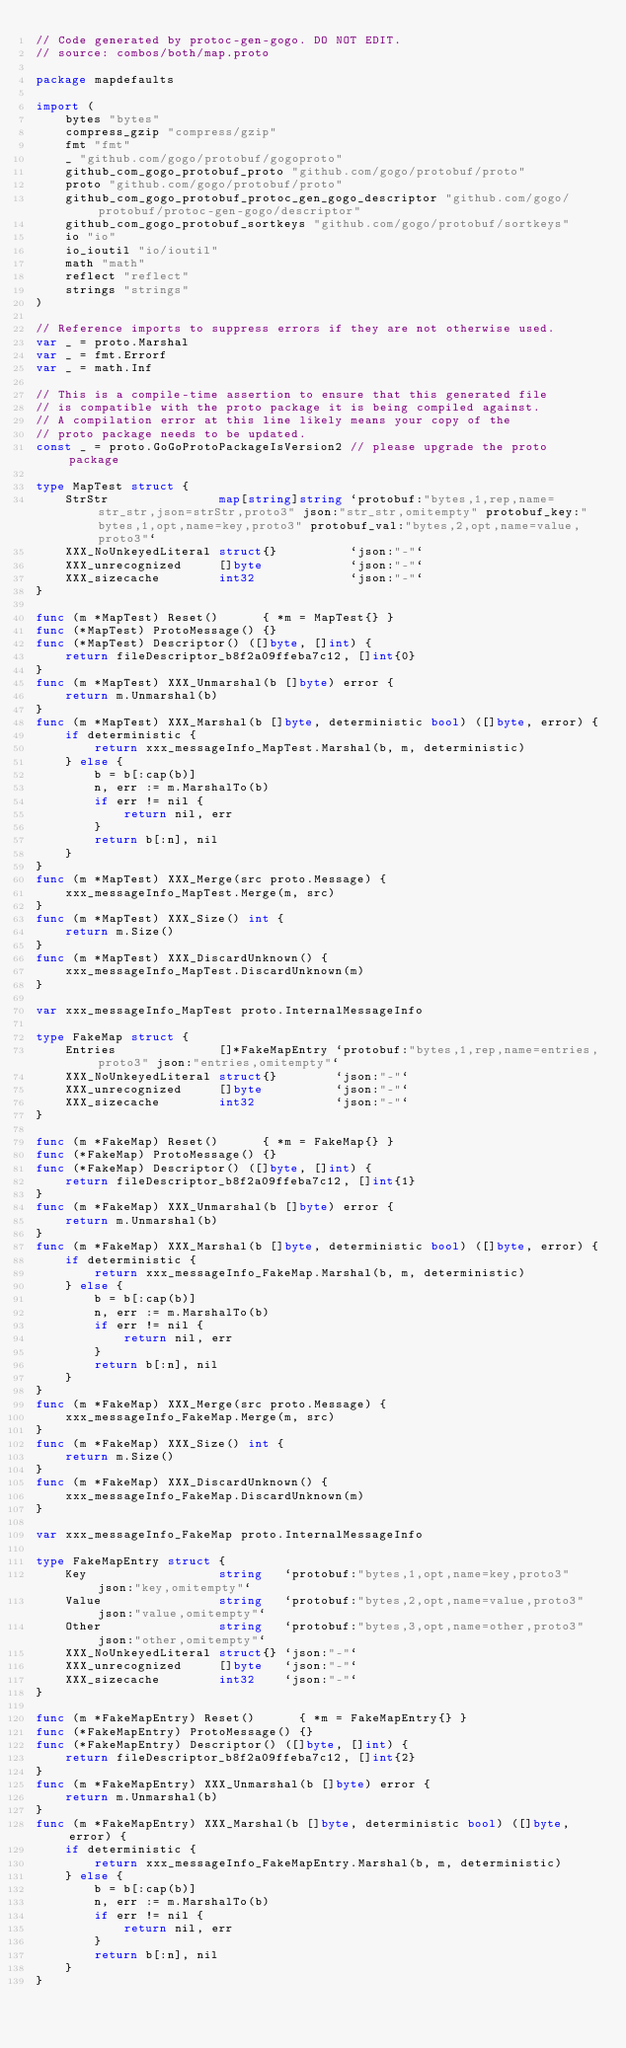<code> <loc_0><loc_0><loc_500><loc_500><_Go_>// Code generated by protoc-gen-gogo. DO NOT EDIT.
// source: combos/both/map.proto

package mapdefaults

import (
	bytes "bytes"
	compress_gzip "compress/gzip"
	fmt "fmt"
	_ "github.com/gogo/protobuf/gogoproto"
	github_com_gogo_protobuf_proto "github.com/gogo/protobuf/proto"
	proto "github.com/gogo/protobuf/proto"
	github_com_gogo_protobuf_protoc_gen_gogo_descriptor "github.com/gogo/protobuf/protoc-gen-gogo/descriptor"
	github_com_gogo_protobuf_sortkeys "github.com/gogo/protobuf/sortkeys"
	io "io"
	io_ioutil "io/ioutil"
	math "math"
	reflect "reflect"
	strings "strings"
)

// Reference imports to suppress errors if they are not otherwise used.
var _ = proto.Marshal
var _ = fmt.Errorf
var _ = math.Inf

// This is a compile-time assertion to ensure that this generated file
// is compatible with the proto package it is being compiled against.
// A compilation error at this line likely means your copy of the
// proto package needs to be updated.
const _ = proto.GoGoProtoPackageIsVersion2 // please upgrade the proto package

type MapTest struct {
	StrStr               map[string]string `protobuf:"bytes,1,rep,name=str_str,json=strStr,proto3" json:"str_str,omitempty" protobuf_key:"bytes,1,opt,name=key,proto3" protobuf_val:"bytes,2,opt,name=value,proto3"`
	XXX_NoUnkeyedLiteral struct{}          `json:"-"`
	XXX_unrecognized     []byte            `json:"-"`
	XXX_sizecache        int32             `json:"-"`
}

func (m *MapTest) Reset()      { *m = MapTest{} }
func (*MapTest) ProtoMessage() {}
func (*MapTest) Descriptor() ([]byte, []int) {
	return fileDescriptor_b8f2a09ffeba7c12, []int{0}
}
func (m *MapTest) XXX_Unmarshal(b []byte) error {
	return m.Unmarshal(b)
}
func (m *MapTest) XXX_Marshal(b []byte, deterministic bool) ([]byte, error) {
	if deterministic {
		return xxx_messageInfo_MapTest.Marshal(b, m, deterministic)
	} else {
		b = b[:cap(b)]
		n, err := m.MarshalTo(b)
		if err != nil {
			return nil, err
		}
		return b[:n], nil
	}
}
func (m *MapTest) XXX_Merge(src proto.Message) {
	xxx_messageInfo_MapTest.Merge(m, src)
}
func (m *MapTest) XXX_Size() int {
	return m.Size()
}
func (m *MapTest) XXX_DiscardUnknown() {
	xxx_messageInfo_MapTest.DiscardUnknown(m)
}

var xxx_messageInfo_MapTest proto.InternalMessageInfo

type FakeMap struct {
	Entries              []*FakeMapEntry `protobuf:"bytes,1,rep,name=entries,proto3" json:"entries,omitempty"`
	XXX_NoUnkeyedLiteral struct{}        `json:"-"`
	XXX_unrecognized     []byte          `json:"-"`
	XXX_sizecache        int32           `json:"-"`
}

func (m *FakeMap) Reset()      { *m = FakeMap{} }
func (*FakeMap) ProtoMessage() {}
func (*FakeMap) Descriptor() ([]byte, []int) {
	return fileDescriptor_b8f2a09ffeba7c12, []int{1}
}
func (m *FakeMap) XXX_Unmarshal(b []byte) error {
	return m.Unmarshal(b)
}
func (m *FakeMap) XXX_Marshal(b []byte, deterministic bool) ([]byte, error) {
	if deterministic {
		return xxx_messageInfo_FakeMap.Marshal(b, m, deterministic)
	} else {
		b = b[:cap(b)]
		n, err := m.MarshalTo(b)
		if err != nil {
			return nil, err
		}
		return b[:n], nil
	}
}
func (m *FakeMap) XXX_Merge(src proto.Message) {
	xxx_messageInfo_FakeMap.Merge(m, src)
}
func (m *FakeMap) XXX_Size() int {
	return m.Size()
}
func (m *FakeMap) XXX_DiscardUnknown() {
	xxx_messageInfo_FakeMap.DiscardUnknown(m)
}

var xxx_messageInfo_FakeMap proto.InternalMessageInfo

type FakeMapEntry struct {
	Key                  string   `protobuf:"bytes,1,opt,name=key,proto3" json:"key,omitempty"`
	Value                string   `protobuf:"bytes,2,opt,name=value,proto3" json:"value,omitempty"`
	Other                string   `protobuf:"bytes,3,opt,name=other,proto3" json:"other,omitempty"`
	XXX_NoUnkeyedLiteral struct{} `json:"-"`
	XXX_unrecognized     []byte   `json:"-"`
	XXX_sizecache        int32    `json:"-"`
}

func (m *FakeMapEntry) Reset()      { *m = FakeMapEntry{} }
func (*FakeMapEntry) ProtoMessage() {}
func (*FakeMapEntry) Descriptor() ([]byte, []int) {
	return fileDescriptor_b8f2a09ffeba7c12, []int{2}
}
func (m *FakeMapEntry) XXX_Unmarshal(b []byte) error {
	return m.Unmarshal(b)
}
func (m *FakeMapEntry) XXX_Marshal(b []byte, deterministic bool) ([]byte, error) {
	if deterministic {
		return xxx_messageInfo_FakeMapEntry.Marshal(b, m, deterministic)
	} else {
		b = b[:cap(b)]
		n, err := m.MarshalTo(b)
		if err != nil {
			return nil, err
		}
		return b[:n], nil
	}
}</code> 